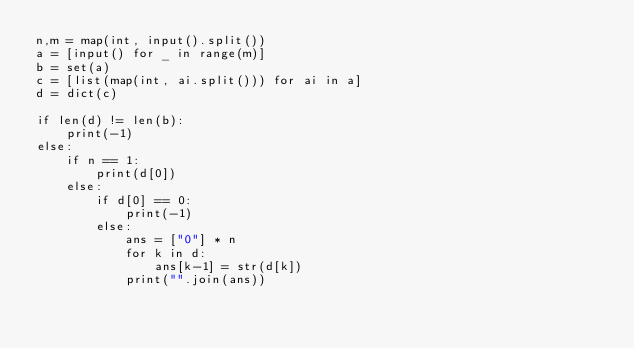Convert code to text. <code><loc_0><loc_0><loc_500><loc_500><_Python_>n,m = map(int, input().split())
a = [input() for _ in range(m)]
b = set(a)
c = [list(map(int, ai.split())) for ai in a]
d = dict(c)

if len(d) != len(b):
    print(-1)
else:
    if n == 1:
        print(d[0])
    else:
        if d[0] == 0:
            print(-1)
        else:
            ans = ["0"] * n
            for k in d:
                ans[k-1] = str(d[k])
            print("".join(ans))
</code> 